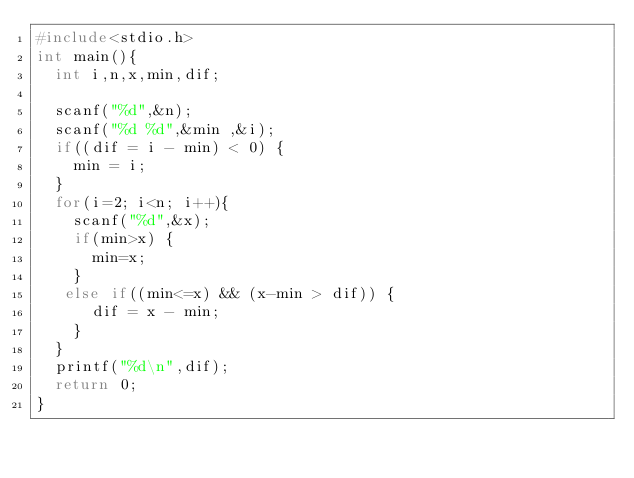Convert code to text. <code><loc_0><loc_0><loc_500><loc_500><_C_>#include<stdio.h>
int main(){
  int i,n,x,min,dif;
  
  scanf("%d",&n);
  scanf("%d %d",&min ,&i);
  if((dif = i - min) < 0) {
    min = i;
  }
  for(i=2; i<n; i++){
    scanf("%d",&x);
    if(min>x) {
      min=x;
    }
   else if((min<=x) && (x-min > dif)) {
      dif = x - min;
    }
  }
  printf("%d\n",dif);
  return 0;
}
</code> 